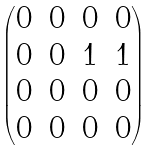Convert formula to latex. <formula><loc_0><loc_0><loc_500><loc_500>\begin{pmatrix} 0 & 0 & 0 & 0 \\ 0 & 0 & 1 & 1 \\ 0 & 0 & 0 & 0 \\ 0 & 0 & 0 & 0 \end{pmatrix}</formula> 